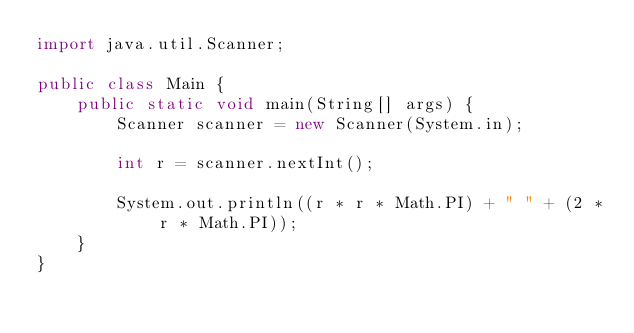Convert code to text. <code><loc_0><loc_0><loc_500><loc_500><_Java_>import java.util.Scanner;

public class Main {
	public static void main(String[] args) {
		Scanner scanner = new Scanner(System.in);
		
		int r = scanner.nextInt();
		
		System.out.println((r * r * Math.PI) + " " + (2 * r * Math.PI));
	}
} 

</code> 